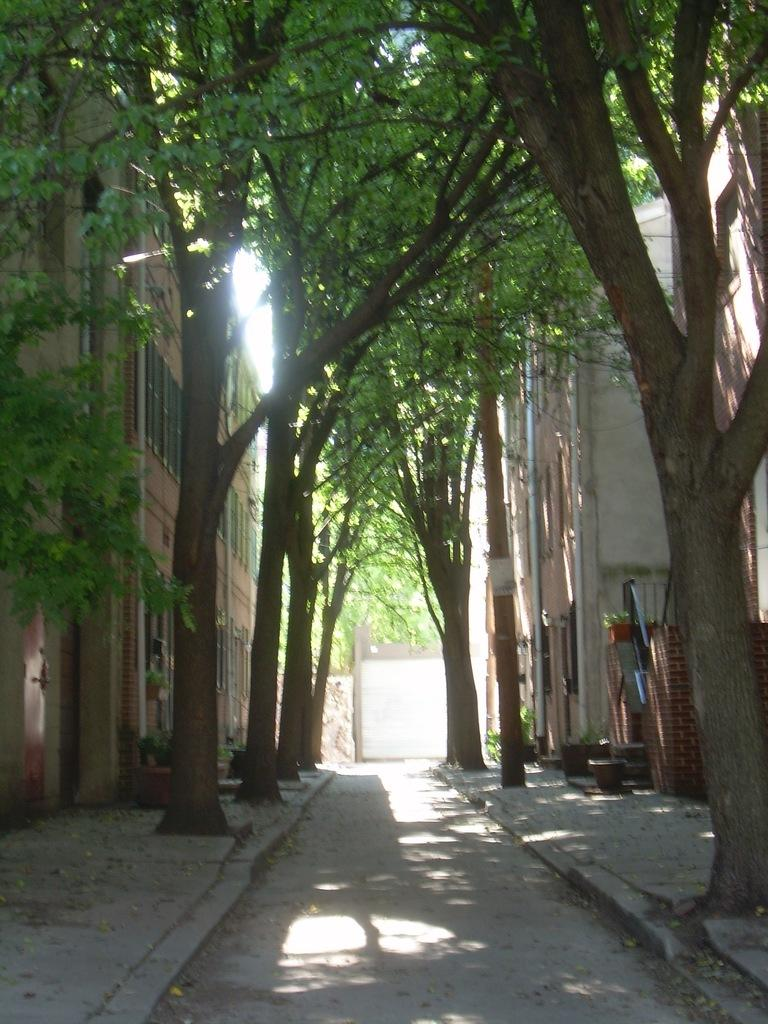What is there is a road in the image, what is its location? The road is at the bottom of the image. What can be seen on both sides of the road? There are trees and buildings on both sides of the road. Are there any footpaths visible in the image? Yes, there is a footpath on the right side of the image and another one on the left side of the image. Can you see a kitten playing with a string on the road? No, there is no kitten or string present in the image. 